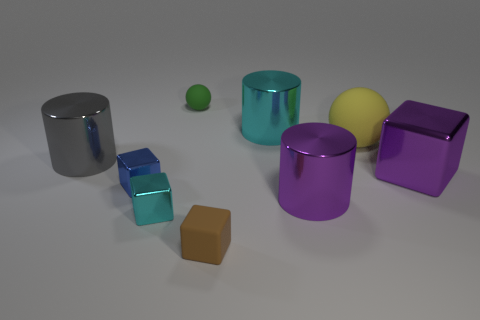Subtract all large purple blocks. How many blocks are left? 3 Subtract 2 cylinders. How many cylinders are left? 1 Add 1 purple matte balls. How many objects exist? 10 Subtract all yellow spheres. How many spheres are left? 1 Subtract all cubes. How many objects are left? 5 Subtract all blue cylinders. How many yellow balls are left? 1 Subtract all large gray cylinders. Subtract all tiny cyan shiny objects. How many objects are left? 7 Add 3 brown cubes. How many brown cubes are left? 4 Add 2 brown rubber things. How many brown rubber things exist? 3 Subtract 1 brown cubes. How many objects are left? 8 